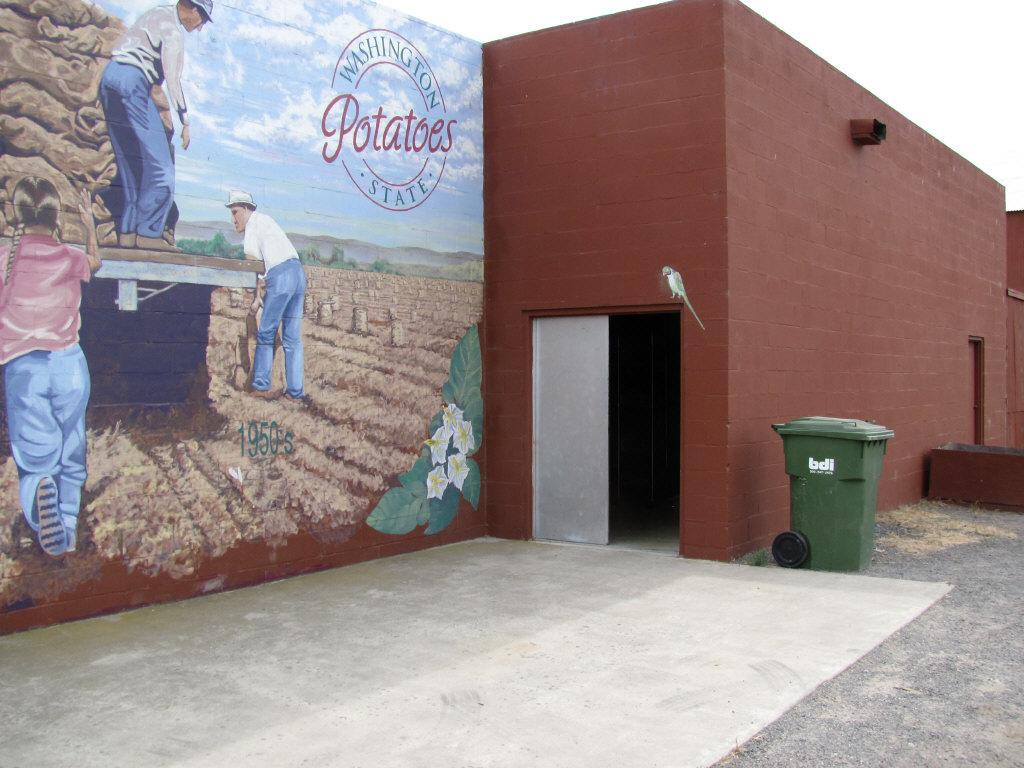Provide a one-sentence caption for the provided image. Drawing on a wall which says Potatoes on it. 